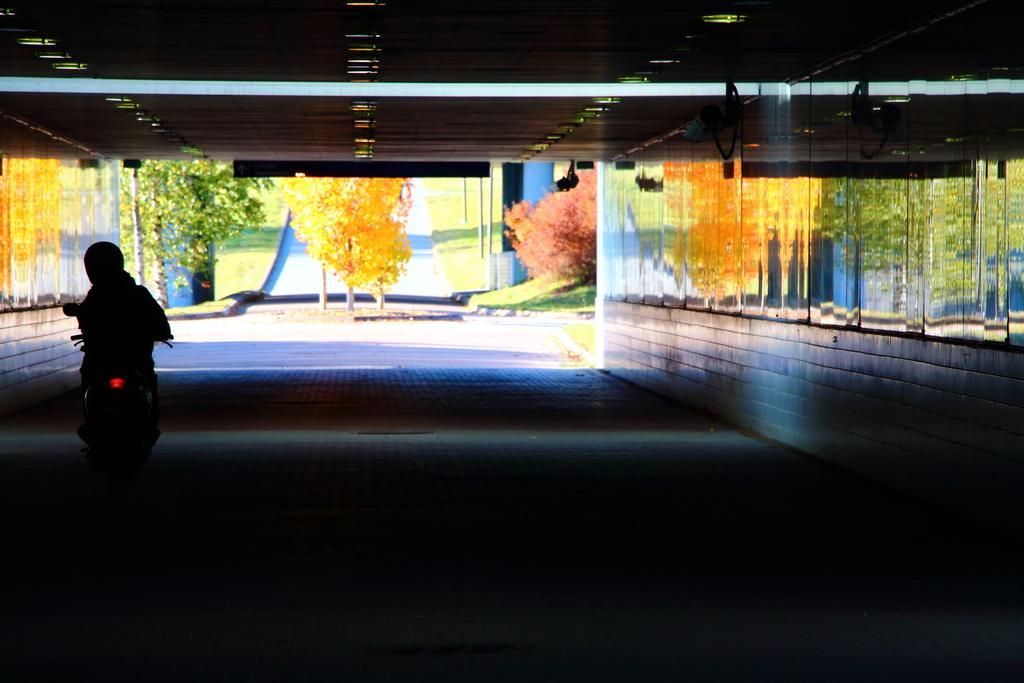How would you summarize this image in a sentence or two? In this picture we can see a person is riding motorcycle on the road, beside to the person we can find few arts on the wall, and also we can see trees and poles. 